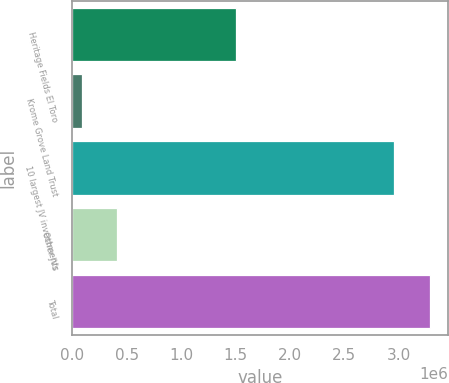Convert chart to OTSL. <chart><loc_0><loc_0><loc_500><loc_500><bar_chart><fcel>Heritage Fields El Toro<fcel>Krome Grove Land Trust<fcel>10 largest JV investments<fcel>Other JVs<fcel>Total<nl><fcel>1.50386e+06<fcel>90622<fcel>2.95915e+06<fcel>410393<fcel>3.28833e+06<nl></chart> 